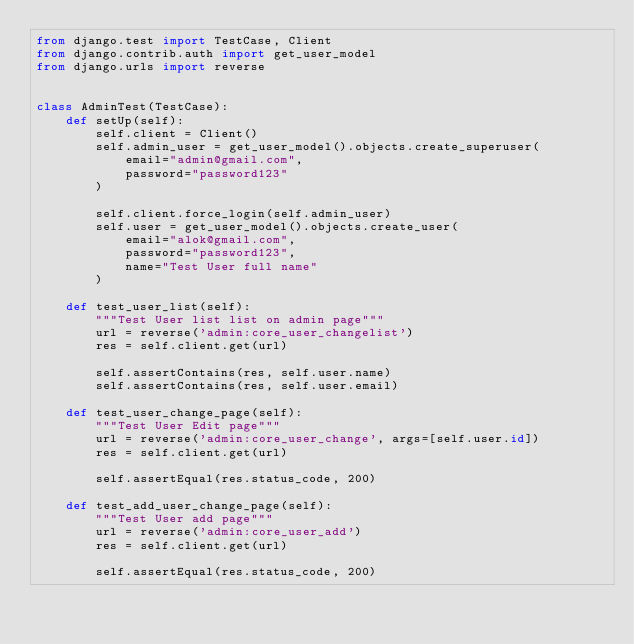Convert code to text. <code><loc_0><loc_0><loc_500><loc_500><_Python_>from django.test import TestCase, Client
from django.contrib.auth import get_user_model
from django.urls import reverse


class AdminTest(TestCase):
    def setUp(self):
        self.client = Client()
        self.admin_user = get_user_model().objects.create_superuser(
            email="admin@gmail.com",
            password="password123"
        )

        self.client.force_login(self.admin_user)
        self.user = get_user_model().objects.create_user(
            email="alok@gmail.com",
            password="password123",
            name="Test User full name"
        )

    def test_user_list(self):
        """Test User list list on admin page"""
        url = reverse('admin:core_user_changelist')
        res = self.client.get(url)

        self.assertContains(res, self.user.name)
        self.assertContains(res, self.user.email)

    def test_user_change_page(self):
        """Test User Edit page"""
        url = reverse('admin:core_user_change', args=[self.user.id])
        res = self.client.get(url)

        self.assertEqual(res.status_code, 200)

    def test_add_user_change_page(self):
        """Test User add page"""
        url = reverse('admin:core_user_add')
        res = self.client.get(url)

        self.assertEqual(res.status_code, 200)
</code> 